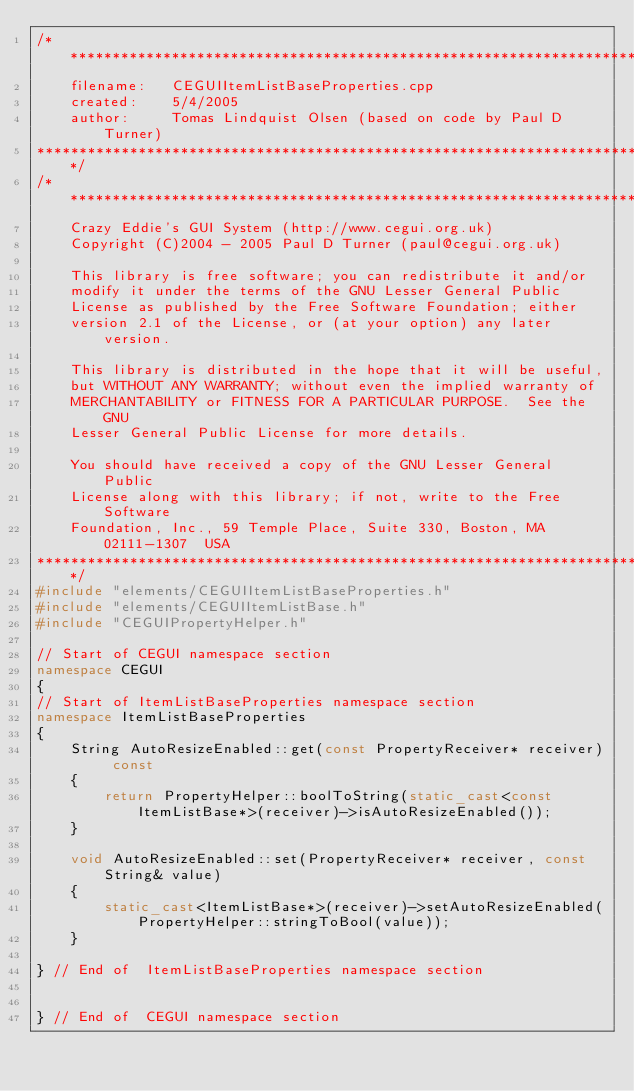Convert code to text. <code><loc_0><loc_0><loc_500><loc_500><_C++_>/************************************************************************
	filename: 	CEGUIItemListBaseProperties.cpp
	created:	5/4/2005
	author:		Tomas Lindquist Olsen (based on code by Paul D Turner)
*************************************************************************/
/*************************************************************************
    Crazy Eddie's GUI System (http://www.cegui.org.uk)
    Copyright (C)2004 - 2005 Paul D Turner (paul@cegui.org.uk)

    This library is free software; you can redistribute it and/or
    modify it under the terms of the GNU Lesser General Public
    License as published by the Free Software Foundation; either
    version 2.1 of the License, or (at your option) any later version.

    This library is distributed in the hope that it will be useful,
    but WITHOUT ANY WARRANTY; without even the implied warranty of
    MERCHANTABILITY or FITNESS FOR A PARTICULAR PURPOSE.  See the GNU
    Lesser General Public License for more details.

    You should have received a copy of the GNU Lesser General Public
    License along with this library; if not, write to the Free Software
    Foundation, Inc., 59 Temple Place, Suite 330, Boston, MA  02111-1307  USA
*************************************************************************/
#include "elements/CEGUIItemListBaseProperties.h"
#include "elements/CEGUIItemListBase.h"
#include "CEGUIPropertyHelper.h"

// Start of CEGUI namespace section
namespace CEGUI
{
// Start of ItemListBaseProperties namespace section
namespace ItemListBaseProperties
{
    String AutoResizeEnabled::get(const PropertyReceiver* receiver) const
    {
        return PropertyHelper::boolToString(static_cast<const ItemListBase*>(receiver)->isAutoResizeEnabled());
    }

    void AutoResizeEnabled::set(PropertyReceiver* receiver, const String& value)
    {
        static_cast<ItemListBase*>(receiver)->setAutoResizeEnabled(PropertyHelper::stringToBool(value));
    }

} // End of  ItemListBaseProperties namespace section


} // End of  CEGUI namespace section
</code> 